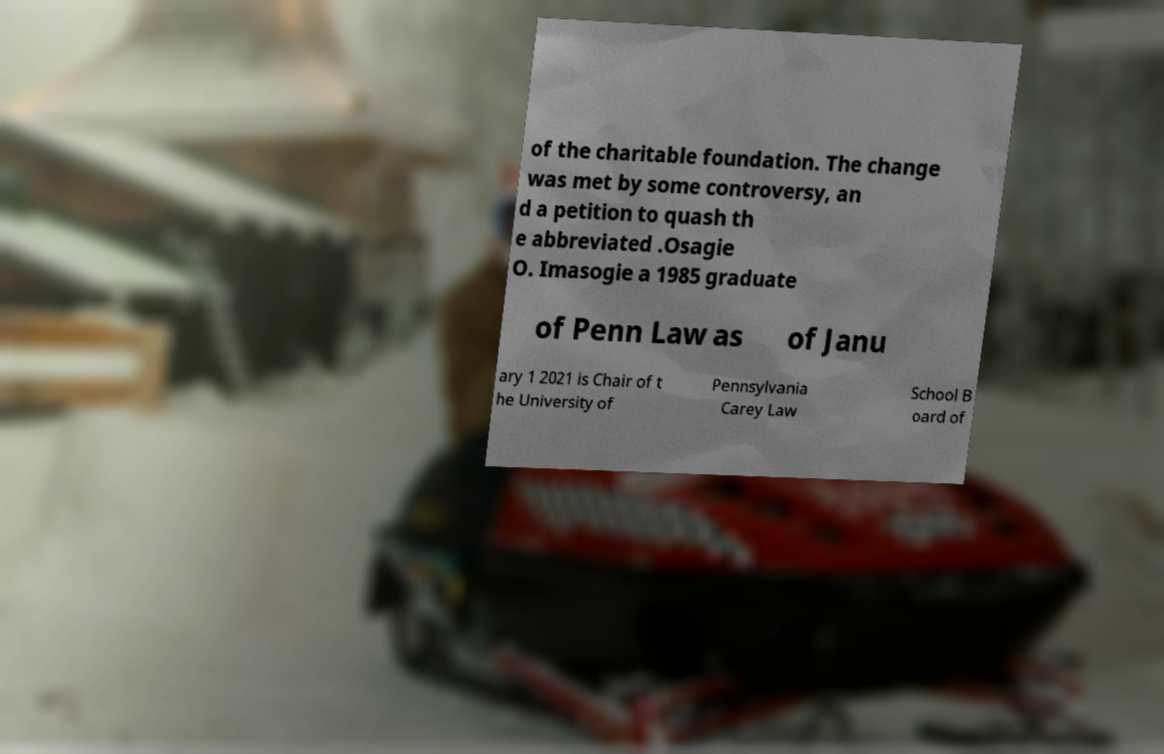Please identify and transcribe the text found in this image. of the charitable foundation. The change was met by some controversy, an d a petition to quash th e abbreviated .Osagie O. Imasogie a 1985 graduate of Penn Law as of Janu ary 1 2021 is Chair of t he University of Pennsylvania Carey Law School B oard of 